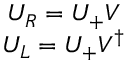Convert formula to latex. <formula><loc_0><loc_0><loc_500><loc_500>\begin{array} { c } { { U _ { R } = U _ { + } V } } \\ { { U _ { L } = U _ { + } V ^ { \dagger } } } \end{array}</formula> 